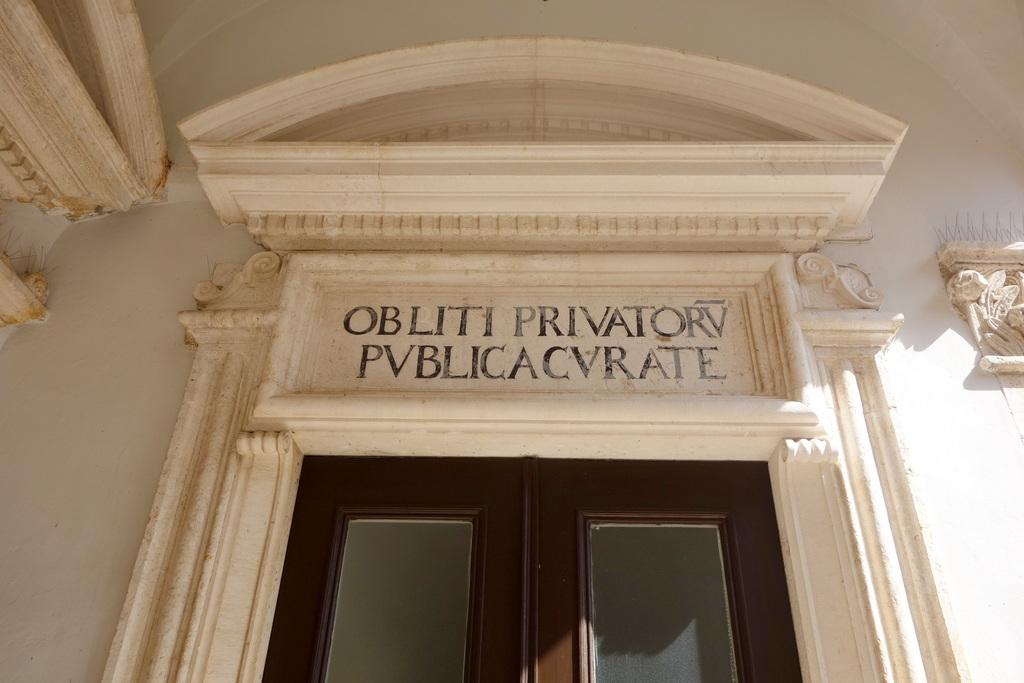What is the main object in the center of the image? There is a name board in the center of the image. Where is the name board located in relation to the door? The name board is above a door. What can be seen in the background of the image? There is a wall in the background of the image. How many planes are parked next to the wall in the image? There are no planes present in the image; it only features a name board above a door and a wall in the background. 